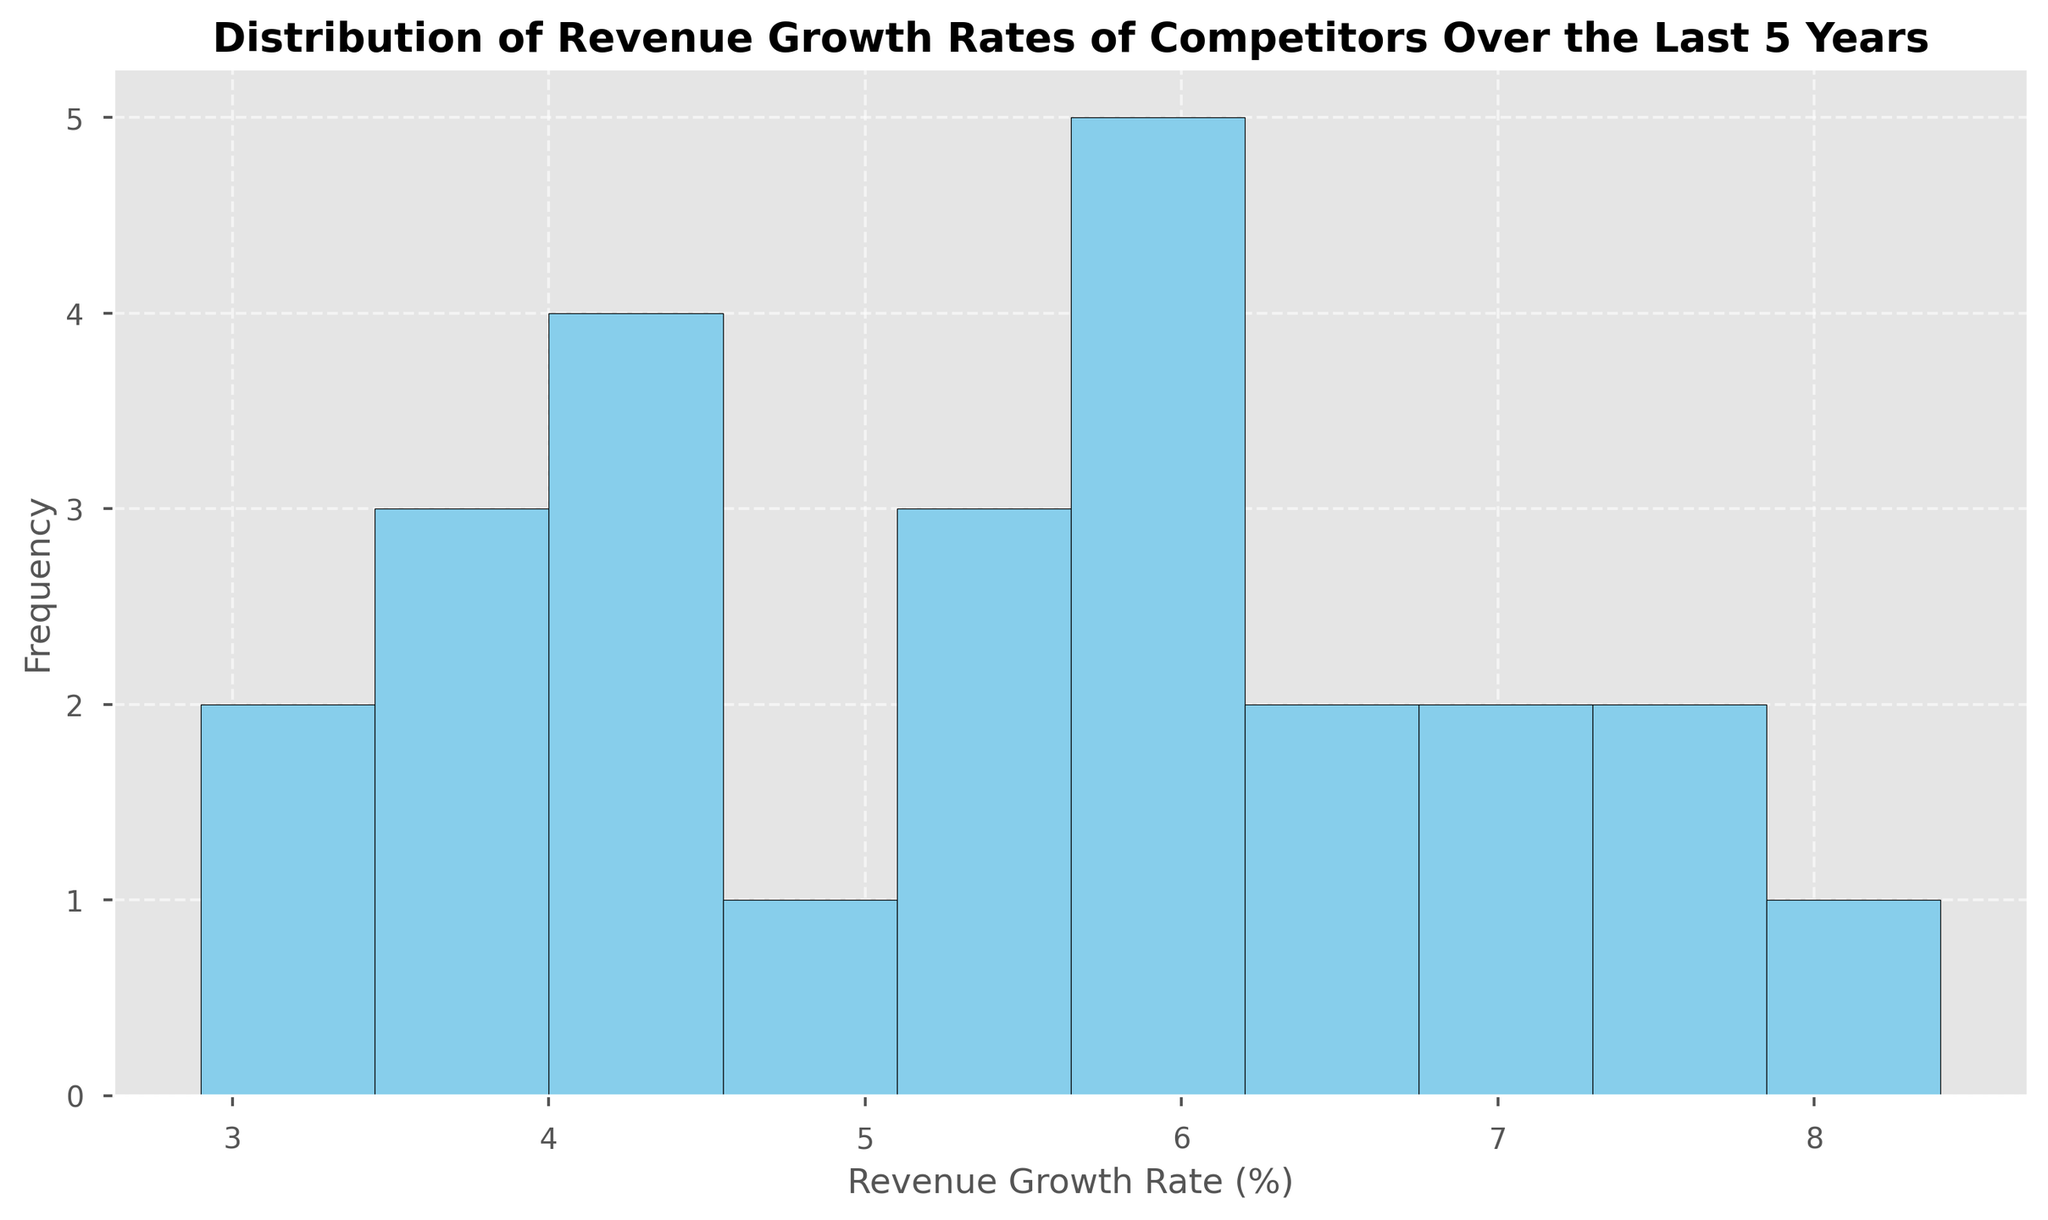What is the most common revenue growth rate range based on the histogram? By looking at the height of the bars, identify which bin has the highest frequency. This indicates the most common or frequent revenue growth rate range.
Answer: The range with the highest frequency is the bin that contains revenue growth rates most often How many revenue growth rates fall between 4% and 6%? Identify the bins that cover the 4% to 6% range and sum the heights of those bars to find the total frequency in that interval.
Answer: The total frequency in the 4% to 6% range What is the average revenue growth rate across all competitors over the last 5 years? Calculate the mean by summing all the revenue growth rates and dividing by the number of data points. For instance, sum of all rates divided by 25 (the total number of data points).
Answer: Average revenue growth rate Which competitor had the highest average growth rate over the specified period? Calculate the mean revenue growth rate for each competitor and compare them to determine which is the highest.
Answer: The competitor with the highest average growth rate How does the frequency of revenue growth rates above 6% compare to those below 3%? Count the number of bars representing rates above 6% and below 3%, and compare their heights.
Answer: Relative frequency comparison Is there any year where a particular growth rate was the most frequent among the competitors? Examine the histogram and identify if there is a common growth rate that occurs more frequently in a particular year for multiple competitors.
Answer: The most frequent growth rate in a specific year Describe the general shape of the distribution of revenue growth rates. Look at the overall pattern of the histogram – identify if it is skewed right, skewed left, or is approximately normal.
Answer: Description of the distribution shape 